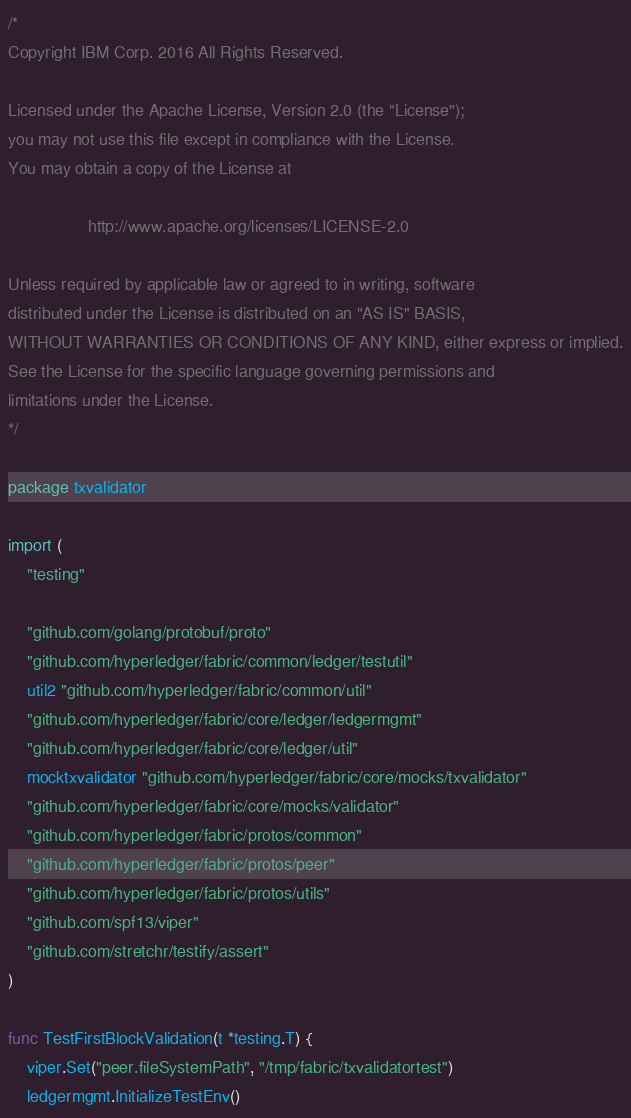Convert code to text. <code><loc_0><loc_0><loc_500><loc_500><_Go_>/*
Copyright IBM Corp. 2016 All Rights Reserved.

Licensed under the Apache License, Version 2.0 (the "License");
you may not use this file except in compliance with the License.
You may obtain a copy of the License at

                 http://www.apache.org/licenses/LICENSE-2.0

Unless required by applicable law or agreed to in writing, software
distributed under the License is distributed on an "AS IS" BASIS,
WITHOUT WARRANTIES OR CONDITIONS OF ANY KIND, either express or implied.
See the License for the specific language governing permissions and
limitations under the License.
*/

package txvalidator

import (
	"testing"

	"github.com/golang/protobuf/proto"
	"github.com/hyperledger/fabric/common/ledger/testutil"
	util2 "github.com/hyperledger/fabric/common/util"
	"github.com/hyperledger/fabric/core/ledger/ledgermgmt"
	"github.com/hyperledger/fabric/core/ledger/util"
	mocktxvalidator "github.com/hyperledger/fabric/core/mocks/txvalidator"
	"github.com/hyperledger/fabric/core/mocks/validator"
	"github.com/hyperledger/fabric/protos/common"
	"github.com/hyperledger/fabric/protos/peer"
	"github.com/hyperledger/fabric/protos/utils"
	"github.com/spf13/viper"
	"github.com/stretchr/testify/assert"
)

func TestFirstBlockValidation(t *testing.T) {
	viper.Set("peer.fileSystemPath", "/tmp/fabric/txvalidatortest")
	ledgermgmt.InitializeTestEnv()</code> 